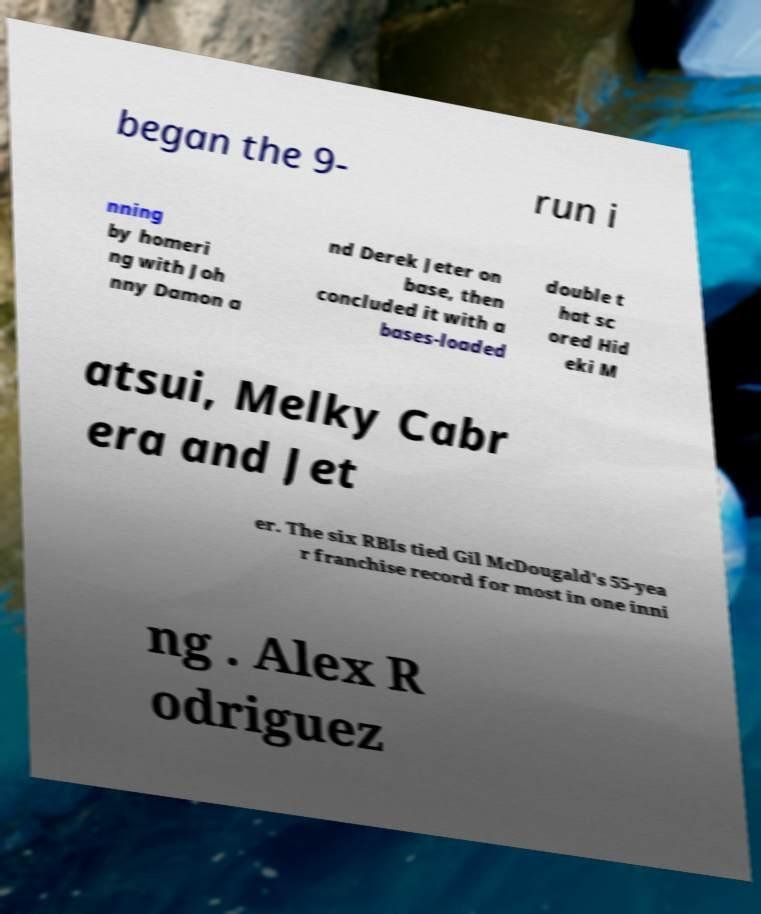Can you read and provide the text displayed in the image?This photo seems to have some interesting text. Can you extract and type it out for me? began the 9- run i nning by homeri ng with Joh nny Damon a nd Derek Jeter on base, then concluded it with a bases-loaded double t hat sc ored Hid eki M atsui, Melky Cabr era and Jet er. The six RBIs tied Gil McDougald's 55-yea r franchise record for most in one inni ng . Alex R odriguez 